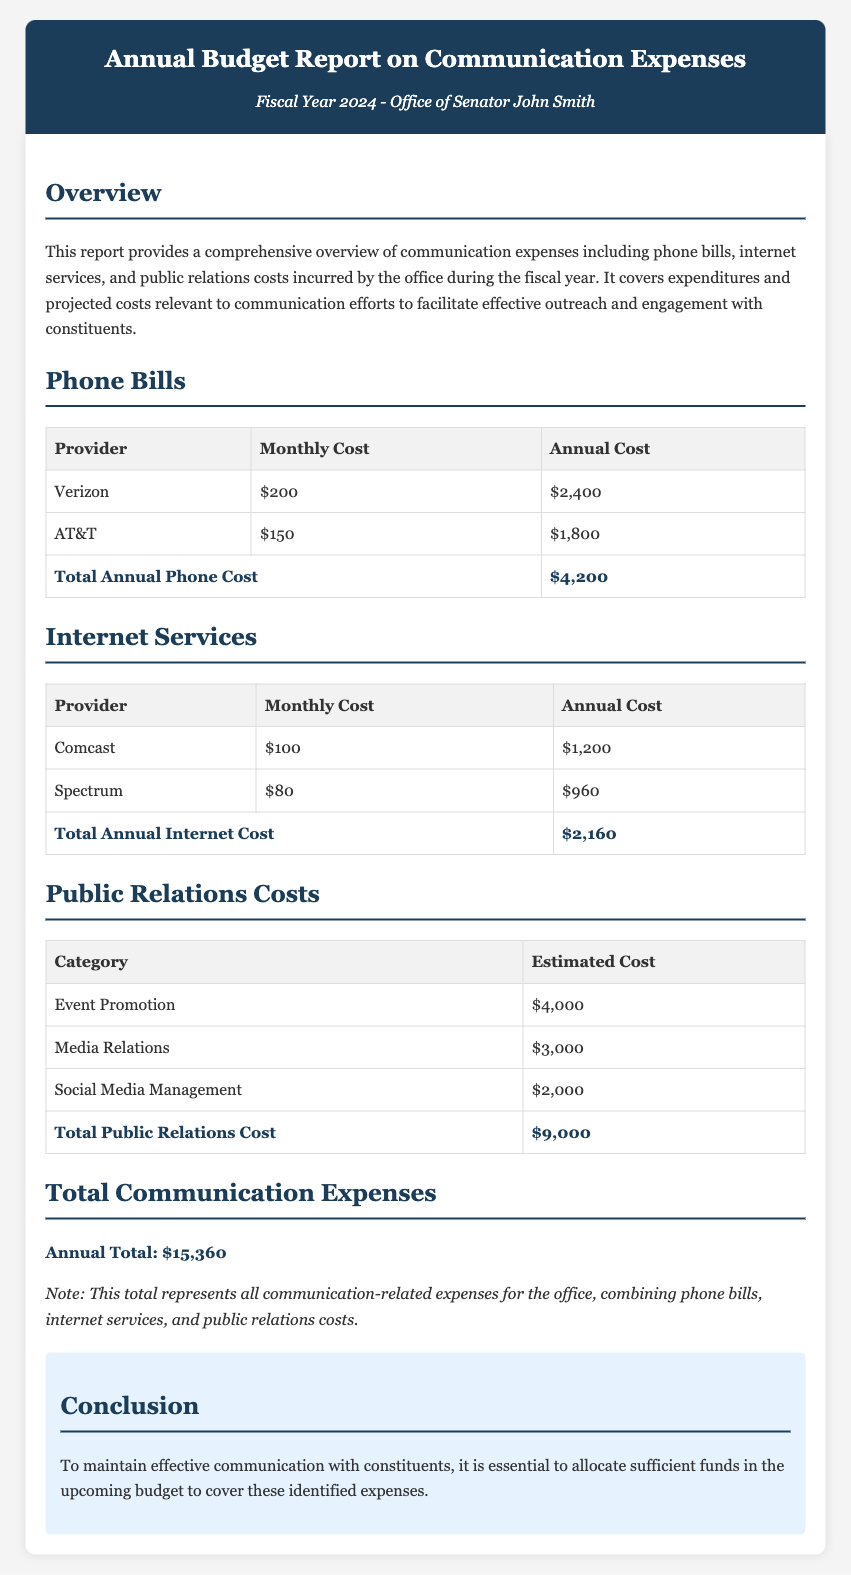What is the total annual phone cost? The total annual phone cost is summarized at the end of the phone bills section, which shows Verizon and AT&T costs combined.
Answer: $4,200 What is the monthly cost for Comcast? The document provides a table of internet services, including the monthly cost for Comcast specifically.
Answer: $100 What are the total public relations costs? The total public relations costs are listed at the end of the public relations costs section after adding up all relevant categories.
Answer: $9,000 What is the total annual expense for communication? The total communication expenses section provides a final figure that combines all areas covered in the report.
Answer: $15,360 Which internet provider has the lowest annual cost? This question requires comparing annual costs from the internet services table to find the provider with the lowest expense.
Answer: Spectrum What is the estimated cost for social media management? The public relations costs table lists the estimated cost specifically for social media management.
Answer: $2,000 What is the purpose of this report? The overview section details the objective of the report regarding communication expenses.
Answer: To provide a comprehensive overview How many providers are listed for phone services? The phone bills section outlines the number of distinct providers in its table.
Answer: 2 What is the conclusion regarding budget allocations? The conclusion section summarizes the essential message about funding for effective communication with constituents.
Answer: Allocate sufficient funds 